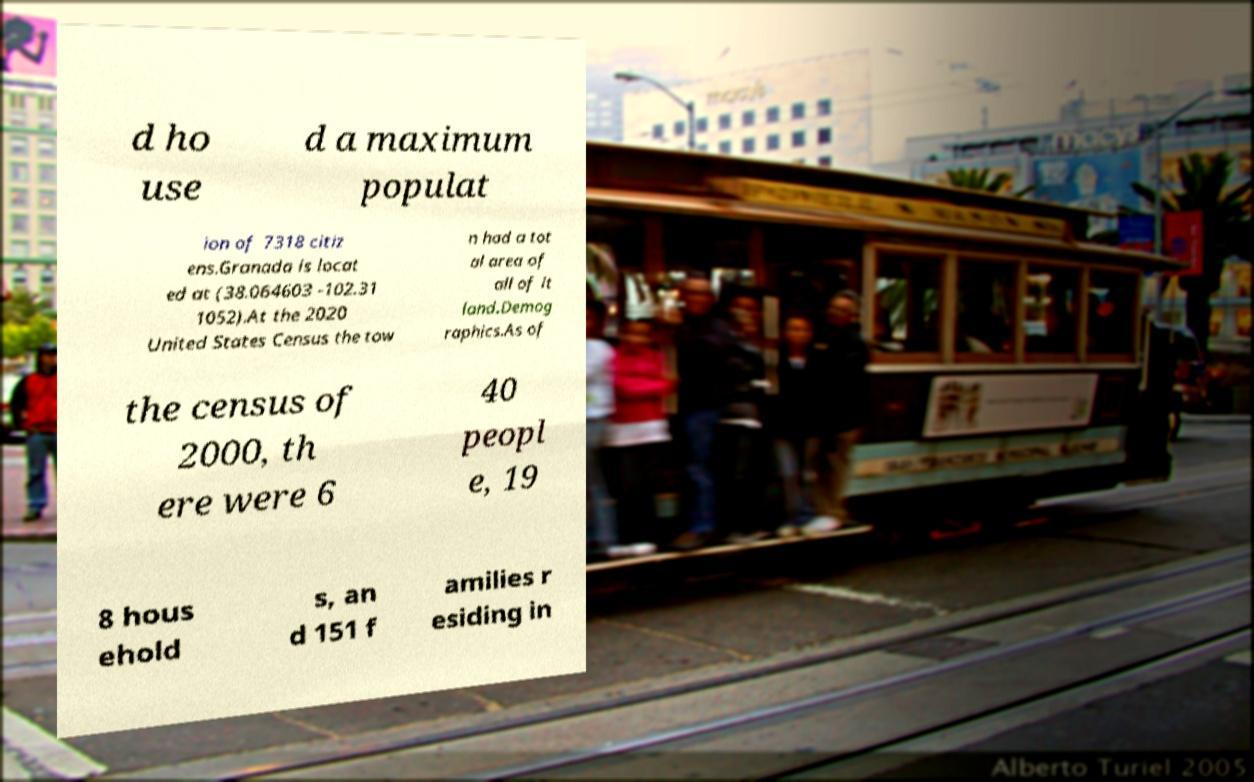For documentation purposes, I need the text within this image transcribed. Could you provide that? d ho use d a maximum populat ion of 7318 citiz ens.Granada is locat ed at (38.064603 -102.31 1052).At the 2020 United States Census the tow n had a tot al area of all of it land.Demog raphics.As of the census of 2000, th ere were 6 40 peopl e, 19 8 hous ehold s, an d 151 f amilies r esiding in 